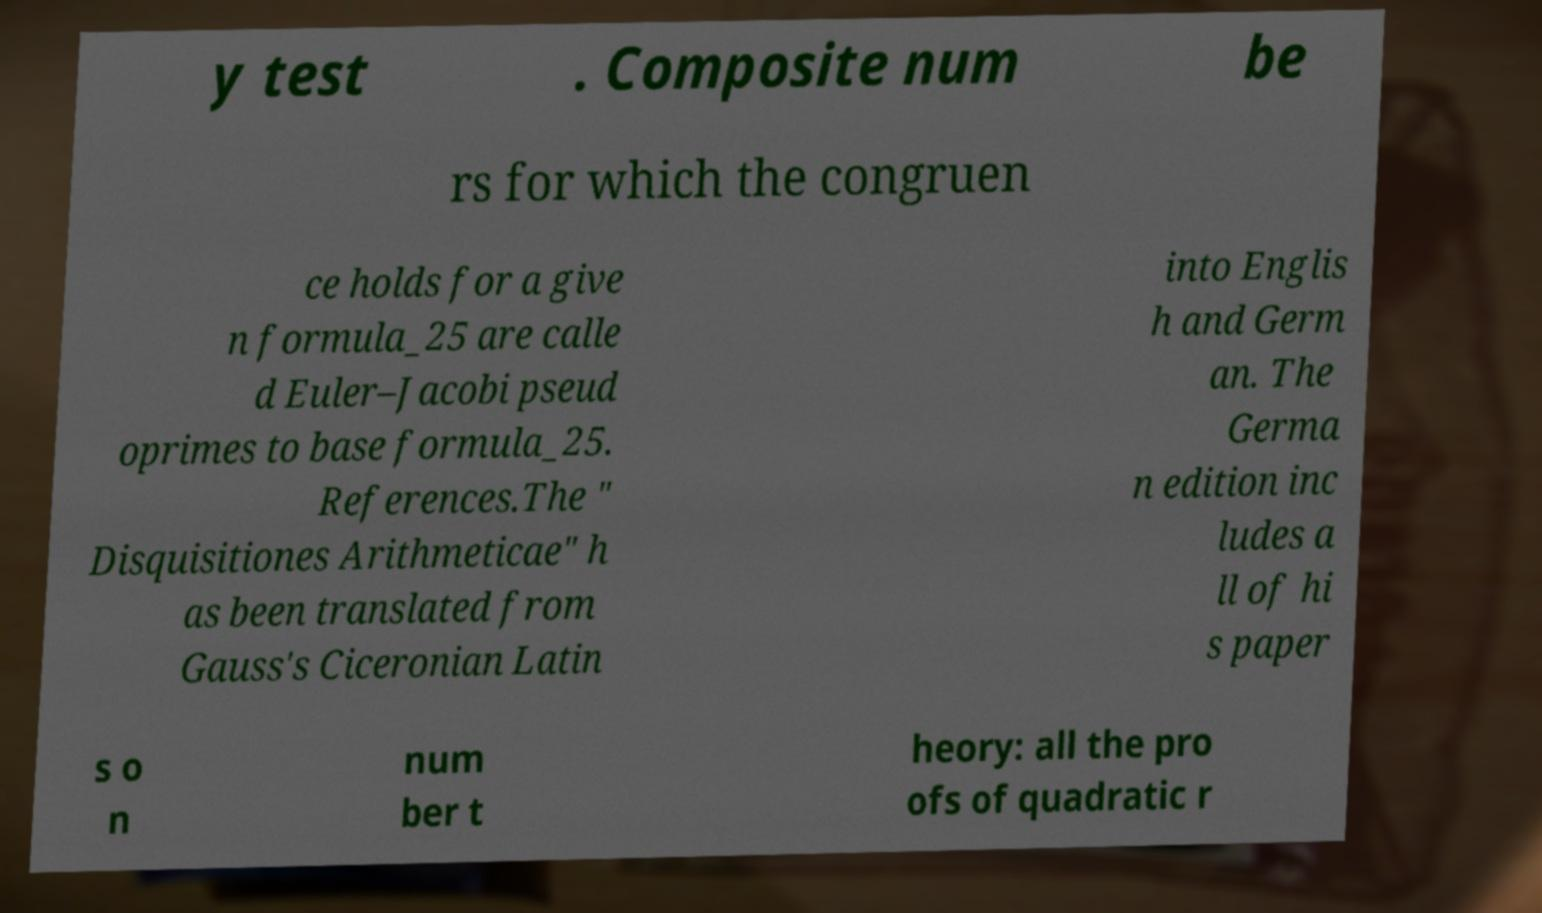Could you extract and type out the text from this image? y test . Composite num be rs for which the congruen ce holds for a give n formula_25 are calle d Euler–Jacobi pseud oprimes to base formula_25. References.The " Disquisitiones Arithmeticae" h as been translated from Gauss's Ciceronian Latin into Englis h and Germ an. The Germa n edition inc ludes a ll of hi s paper s o n num ber t heory: all the pro ofs of quadratic r 